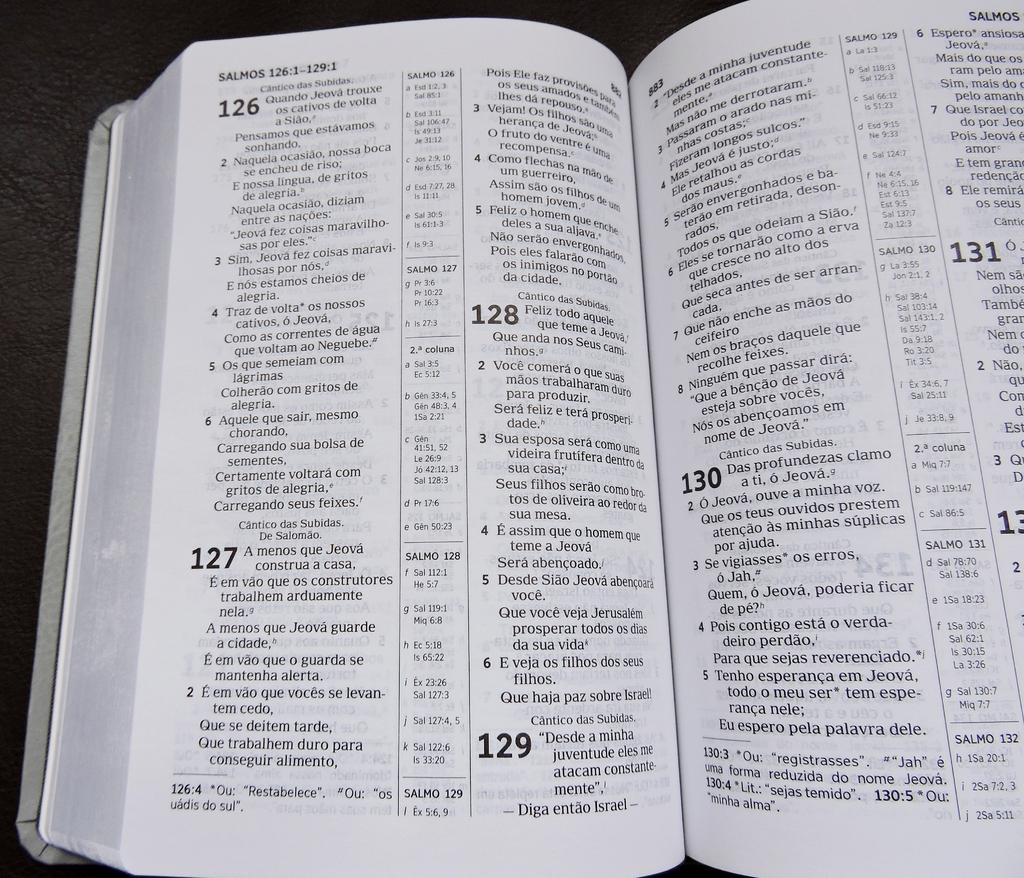<image>
Summarize the visual content of the image. A book of Psalms shows number 126 through number 131. 